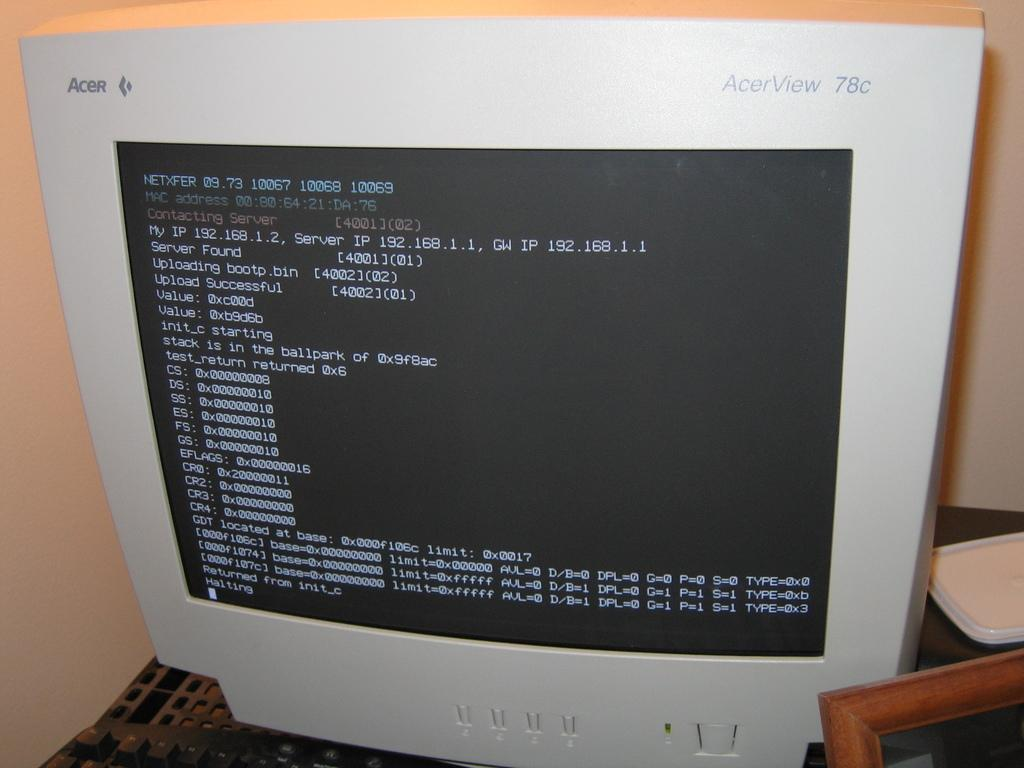<image>
Present a compact description of the photo's key features. an acer monitor with tons of text on it 